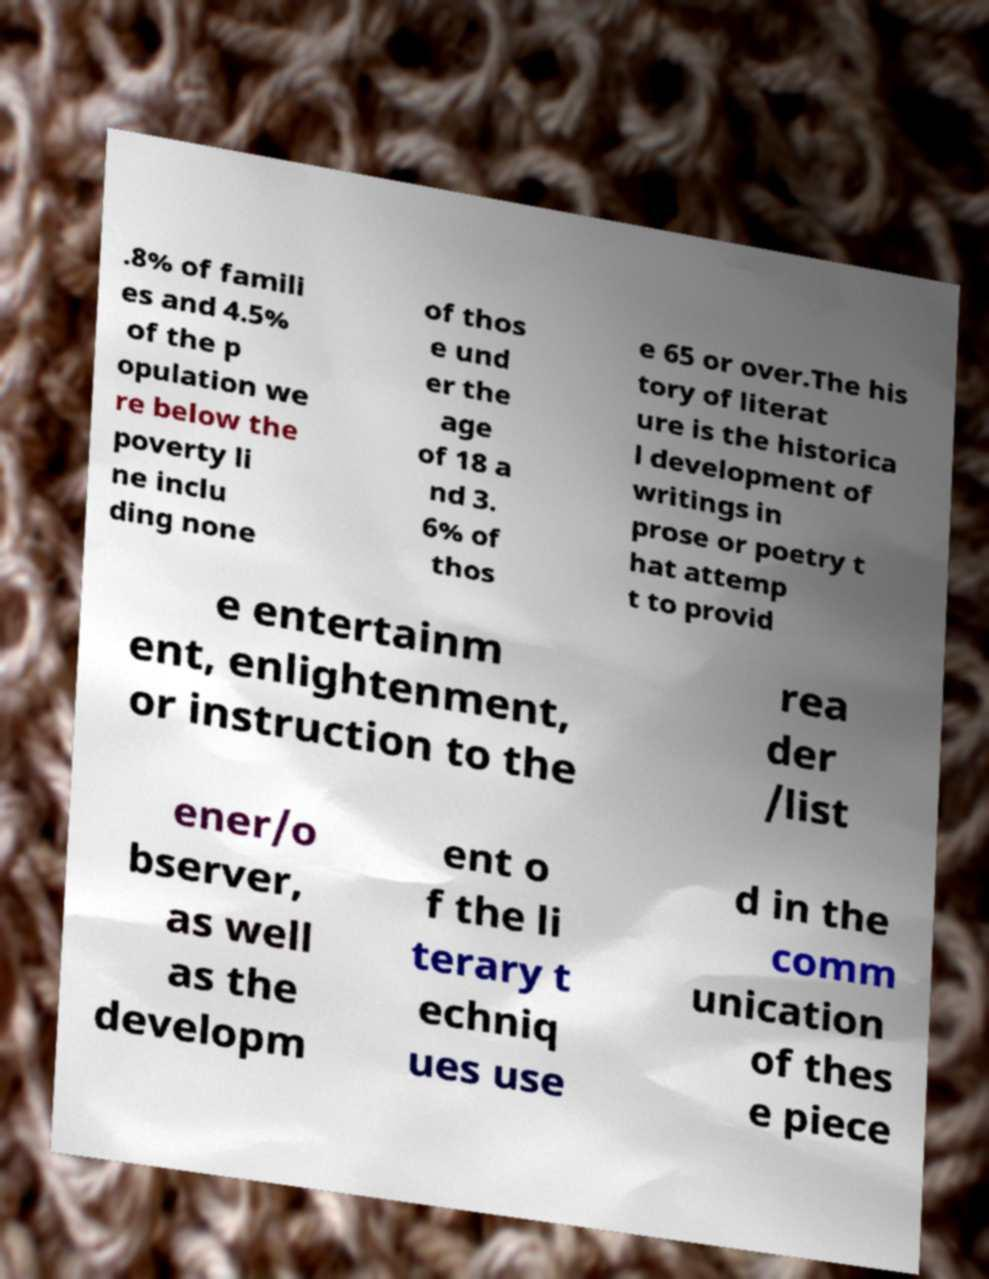Please read and relay the text visible in this image. What does it say? .8% of famili es and 4.5% of the p opulation we re below the poverty li ne inclu ding none of thos e und er the age of 18 a nd 3. 6% of thos e 65 or over.The his tory of literat ure is the historica l development of writings in prose or poetry t hat attemp t to provid e entertainm ent, enlightenment, or instruction to the rea der /list ener/o bserver, as well as the developm ent o f the li terary t echniq ues use d in the comm unication of thes e piece 